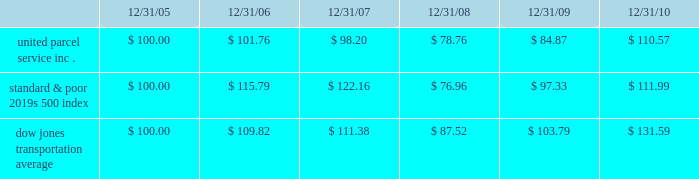Shareowner return performance graph the following performance graph and related information shall not be deemed 201csoliciting material 201d or to be 201cfiled 201d with the securities and exchange commission , nor shall such information be incorporated by reference into any future filing under the securities act of 1933 or securities exchange act of 1934 , each as amended , except to the extent that the company specifically incorporates such information by reference into such filing .
The following graph shows a five year comparison of cumulative total shareowners 2019 returns for our class b common stock , the standard & poor 2019s 500 index , and the dow jones transportation average .
The comparison of the total cumulative return on investment , which is the change in the quarterly stock price plus reinvested dividends for each of the quarterly periods , assumes that $ 100 was invested on december 31 , 2005 in the standard & poor 2019s 500 index , the dow jones transportation average , and our class b common stock .
Comparison of five year cumulative total return $ 40.00 $ 60.00 $ 80.00 $ 100.00 $ 120.00 $ 140.00 $ 160.00 201020092008200720062005 s&p 500 ups dj transport .

What was the percentage cumulative total shareowners 2019 returns for united parcel service inc . for the five years ended 12/31/10? 
Computations: ((110.57 - 100) / 100)
Answer: 0.1057. 